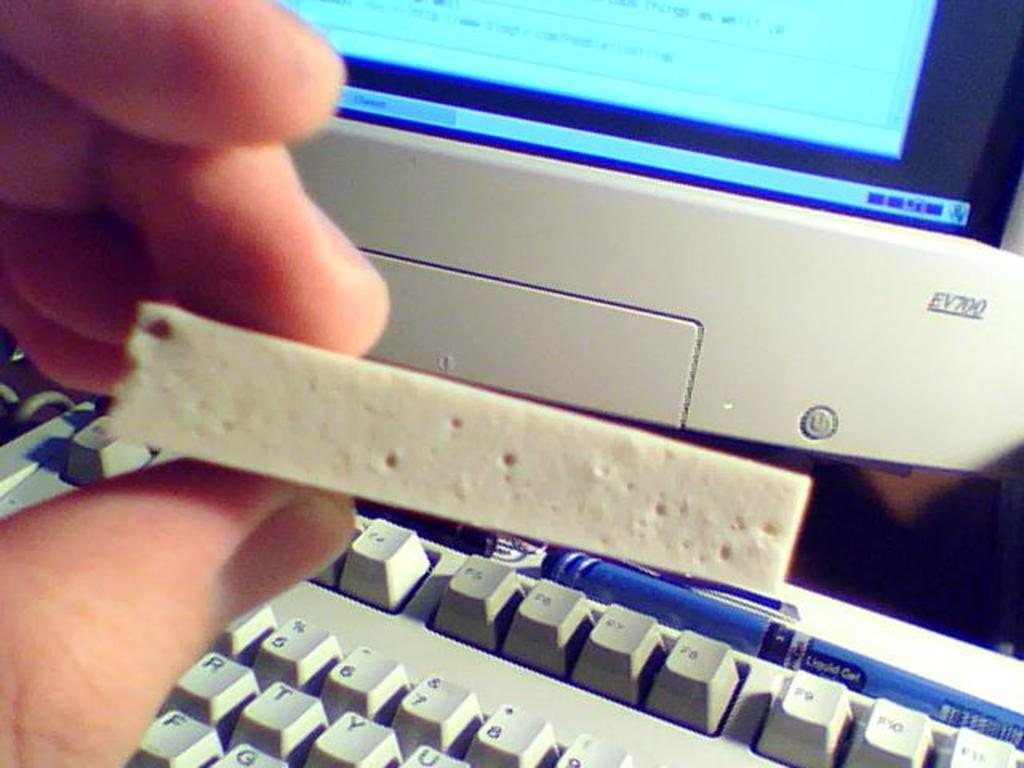Provide a one-sentence caption for the provided image. A person at a computer holding a sponge in front of an EV700 monitor. 